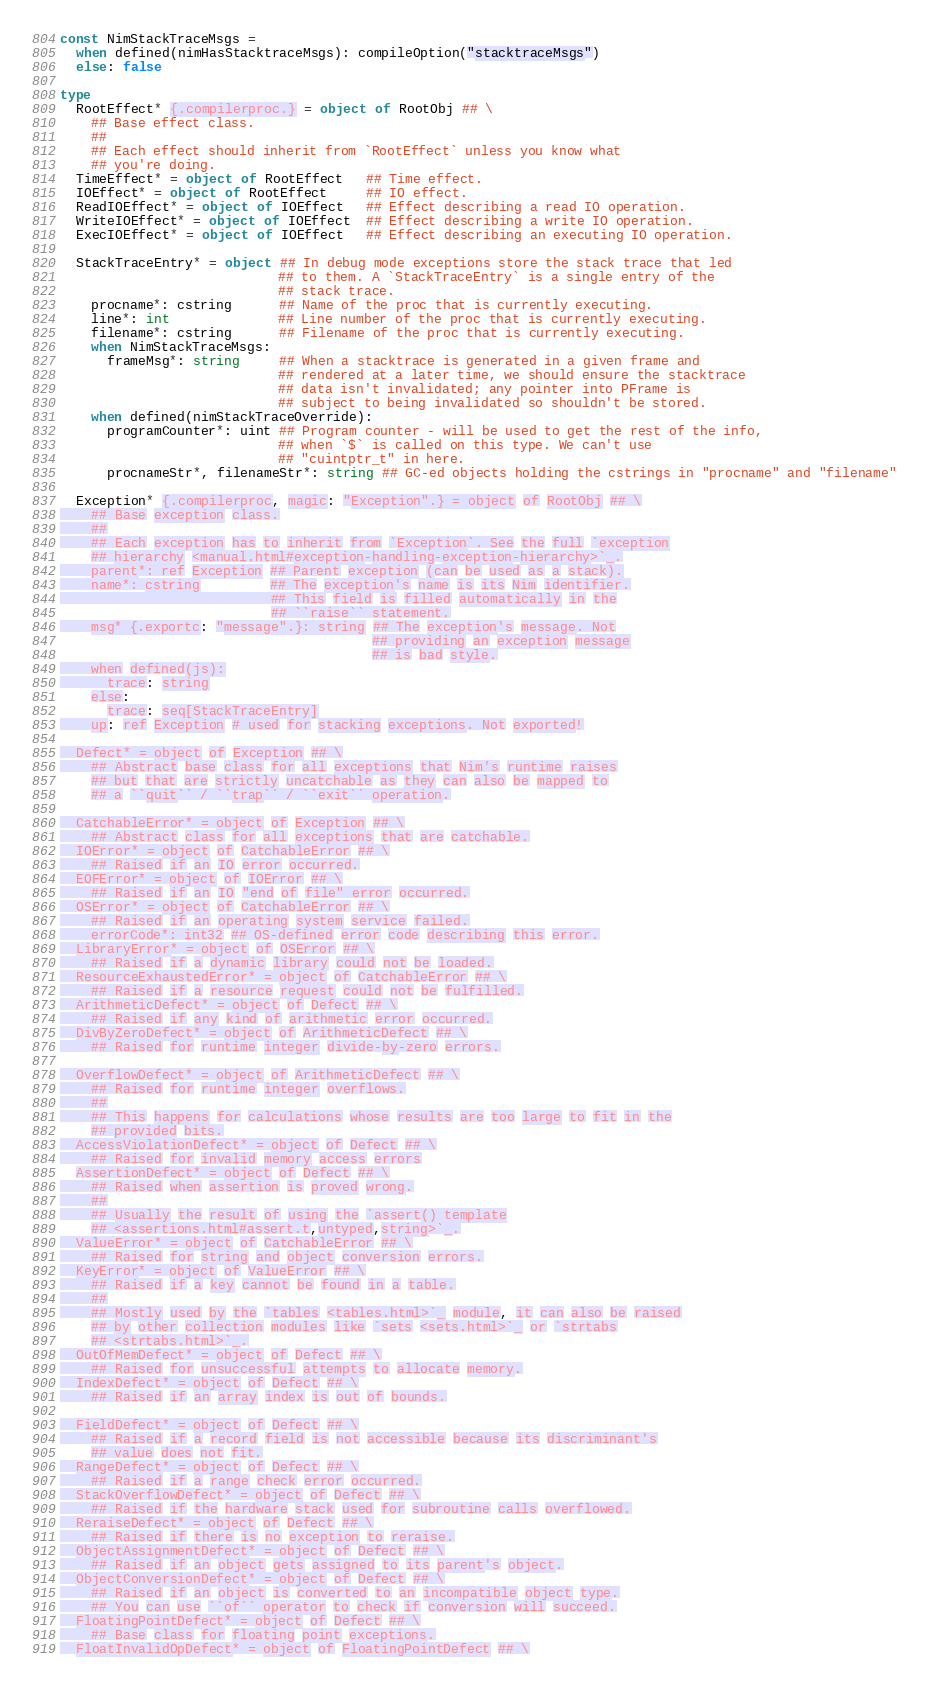Convert code to text. <code><loc_0><loc_0><loc_500><loc_500><_Nim_>const NimStackTraceMsgs =
  when defined(nimHasStacktraceMsgs): compileOption("stacktraceMsgs")
  else: false

type
  RootEffect* {.compilerproc.} = object of RootObj ## \
    ## Base effect class.
    ##
    ## Each effect should inherit from `RootEffect` unless you know what
    ## you're doing.
  TimeEffect* = object of RootEffect   ## Time effect.
  IOEffect* = object of RootEffect     ## IO effect.
  ReadIOEffect* = object of IOEffect   ## Effect describing a read IO operation.
  WriteIOEffect* = object of IOEffect  ## Effect describing a write IO operation.
  ExecIOEffect* = object of IOEffect   ## Effect describing an executing IO operation.

  StackTraceEntry* = object ## In debug mode exceptions store the stack trace that led
                            ## to them. A `StackTraceEntry` is a single entry of the
                            ## stack trace.
    procname*: cstring      ## Name of the proc that is currently executing.
    line*: int              ## Line number of the proc that is currently executing.
    filename*: cstring      ## Filename of the proc that is currently executing.
    when NimStackTraceMsgs:
      frameMsg*: string     ## When a stacktrace is generated in a given frame and
                            ## rendered at a later time, we should ensure the stacktrace
                            ## data isn't invalidated; any pointer into PFrame is
                            ## subject to being invalidated so shouldn't be stored.
    when defined(nimStackTraceOverride):
      programCounter*: uint ## Program counter - will be used to get the rest of the info,
                            ## when `$` is called on this type. We can't use
                            ## "cuintptr_t" in here.
      procnameStr*, filenameStr*: string ## GC-ed objects holding the cstrings in "procname" and "filename"

  Exception* {.compilerproc, magic: "Exception".} = object of RootObj ## \
    ## Base exception class.
    ##
    ## Each exception has to inherit from `Exception`. See the full `exception
    ## hierarchy <manual.html#exception-handling-exception-hierarchy>`_.
    parent*: ref Exception ## Parent exception (can be used as a stack).
    name*: cstring         ## The exception's name is its Nim identifier.
                           ## This field is filled automatically in the
                           ## ``raise`` statement.
    msg* {.exportc: "message".}: string ## The exception's message. Not
                                        ## providing an exception message
                                        ## is bad style.
    when defined(js):
      trace: string
    else:
      trace: seq[StackTraceEntry]
    up: ref Exception # used for stacking exceptions. Not exported!

  Defect* = object of Exception ## \
    ## Abstract base class for all exceptions that Nim's runtime raises
    ## but that are strictly uncatchable as they can also be mapped to
    ## a ``quit`` / ``trap`` / ``exit`` operation.

  CatchableError* = object of Exception ## \
    ## Abstract class for all exceptions that are catchable.
  IOError* = object of CatchableError ## \
    ## Raised if an IO error occurred.
  EOFError* = object of IOError ## \
    ## Raised if an IO "end of file" error occurred.
  OSError* = object of CatchableError ## \
    ## Raised if an operating system service failed.
    errorCode*: int32 ## OS-defined error code describing this error.
  LibraryError* = object of OSError ## \
    ## Raised if a dynamic library could not be loaded.
  ResourceExhaustedError* = object of CatchableError ## \
    ## Raised if a resource request could not be fulfilled.
  ArithmeticDefect* = object of Defect ## \
    ## Raised if any kind of arithmetic error occurred.
  DivByZeroDefect* = object of ArithmeticDefect ## \
    ## Raised for runtime integer divide-by-zero errors.

  OverflowDefect* = object of ArithmeticDefect ## \
    ## Raised for runtime integer overflows.
    ##
    ## This happens for calculations whose results are too large to fit in the
    ## provided bits.
  AccessViolationDefect* = object of Defect ## \
    ## Raised for invalid memory access errors
  AssertionDefect* = object of Defect ## \
    ## Raised when assertion is proved wrong.
    ##
    ## Usually the result of using the `assert() template
    ## <assertions.html#assert.t,untyped,string>`_.
  ValueError* = object of CatchableError ## \
    ## Raised for string and object conversion errors.
  KeyError* = object of ValueError ## \
    ## Raised if a key cannot be found in a table.
    ##
    ## Mostly used by the `tables <tables.html>`_ module, it can also be raised
    ## by other collection modules like `sets <sets.html>`_ or `strtabs
    ## <strtabs.html>`_.
  OutOfMemDefect* = object of Defect ## \
    ## Raised for unsuccessful attempts to allocate memory.
  IndexDefect* = object of Defect ## \
    ## Raised if an array index is out of bounds.

  FieldDefect* = object of Defect ## \
    ## Raised if a record field is not accessible because its discriminant's
    ## value does not fit.
  RangeDefect* = object of Defect ## \
    ## Raised if a range check error occurred.
  StackOverflowDefect* = object of Defect ## \
    ## Raised if the hardware stack used for subroutine calls overflowed.
  ReraiseDefect* = object of Defect ## \
    ## Raised if there is no exception to reraise.
  ObjectAssignmentDefect* = object of Defect ## \
    ## Raised if an object gets assigned to its parent's object.
  ObjectConversionDefect* = object of Defect ## \
    ## Raised if an object is converted to an incompatible object type.
    ## You can use ``of`` operator to check if conversion will succeed.
  FloatingPointDefect* = object of Defect ## \
    ## Base class for floating point exceptions.
  FloatInvalidOpDefect* = object of FloatingPointDefect ## \</code> 